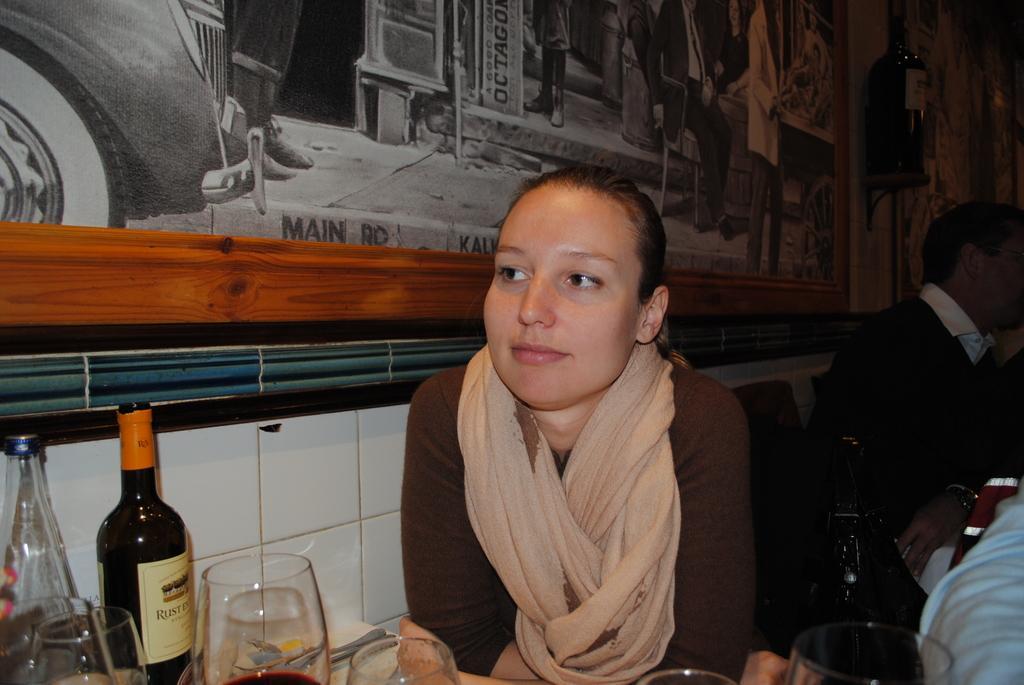Describe this image in one or two sentences. A woman wearing a scarf is sitting. In front of her there is a table. On the table there are bottles, glasses. On the side there is a tile wall also there is a wall painting with photo frame. In the background there are some people sitting. 